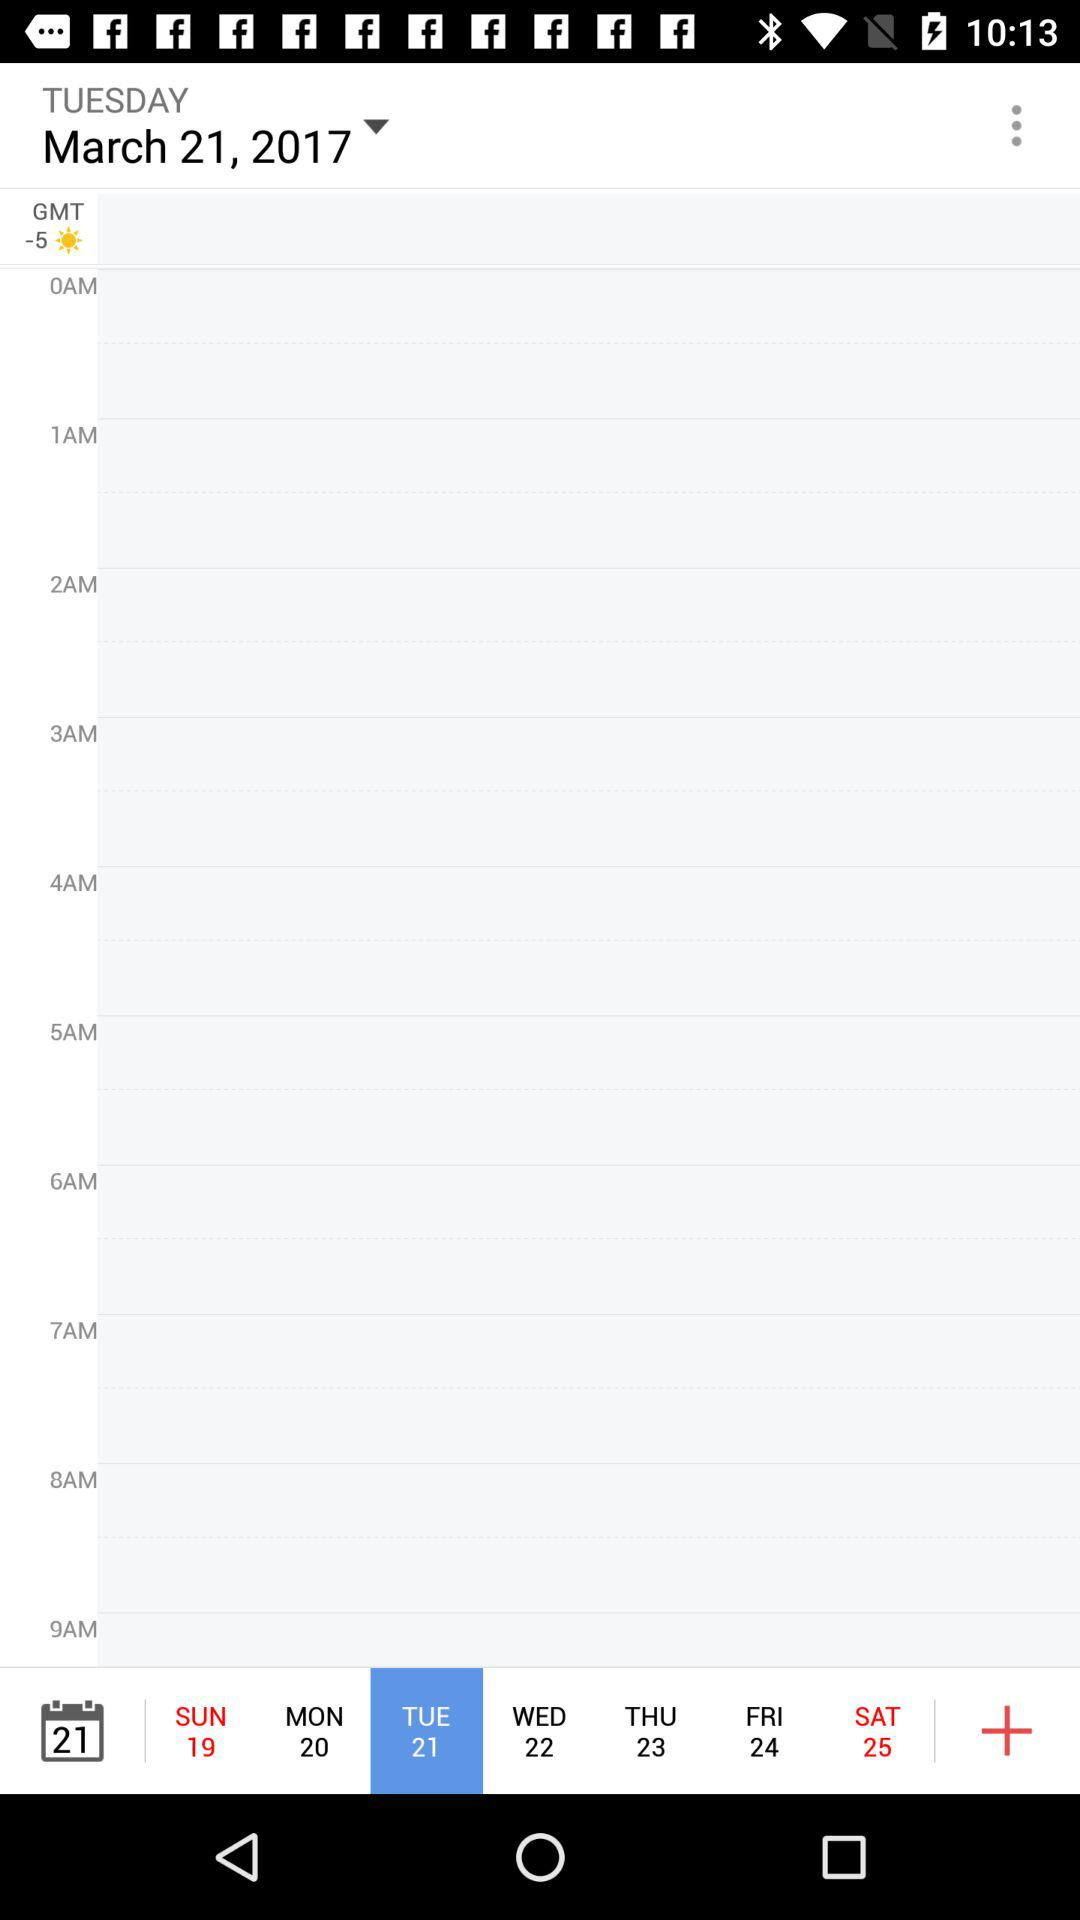What is the time difference between GMT and the time zone displayed in the screenshot?
Answer the question using a single word or phrase. -5 